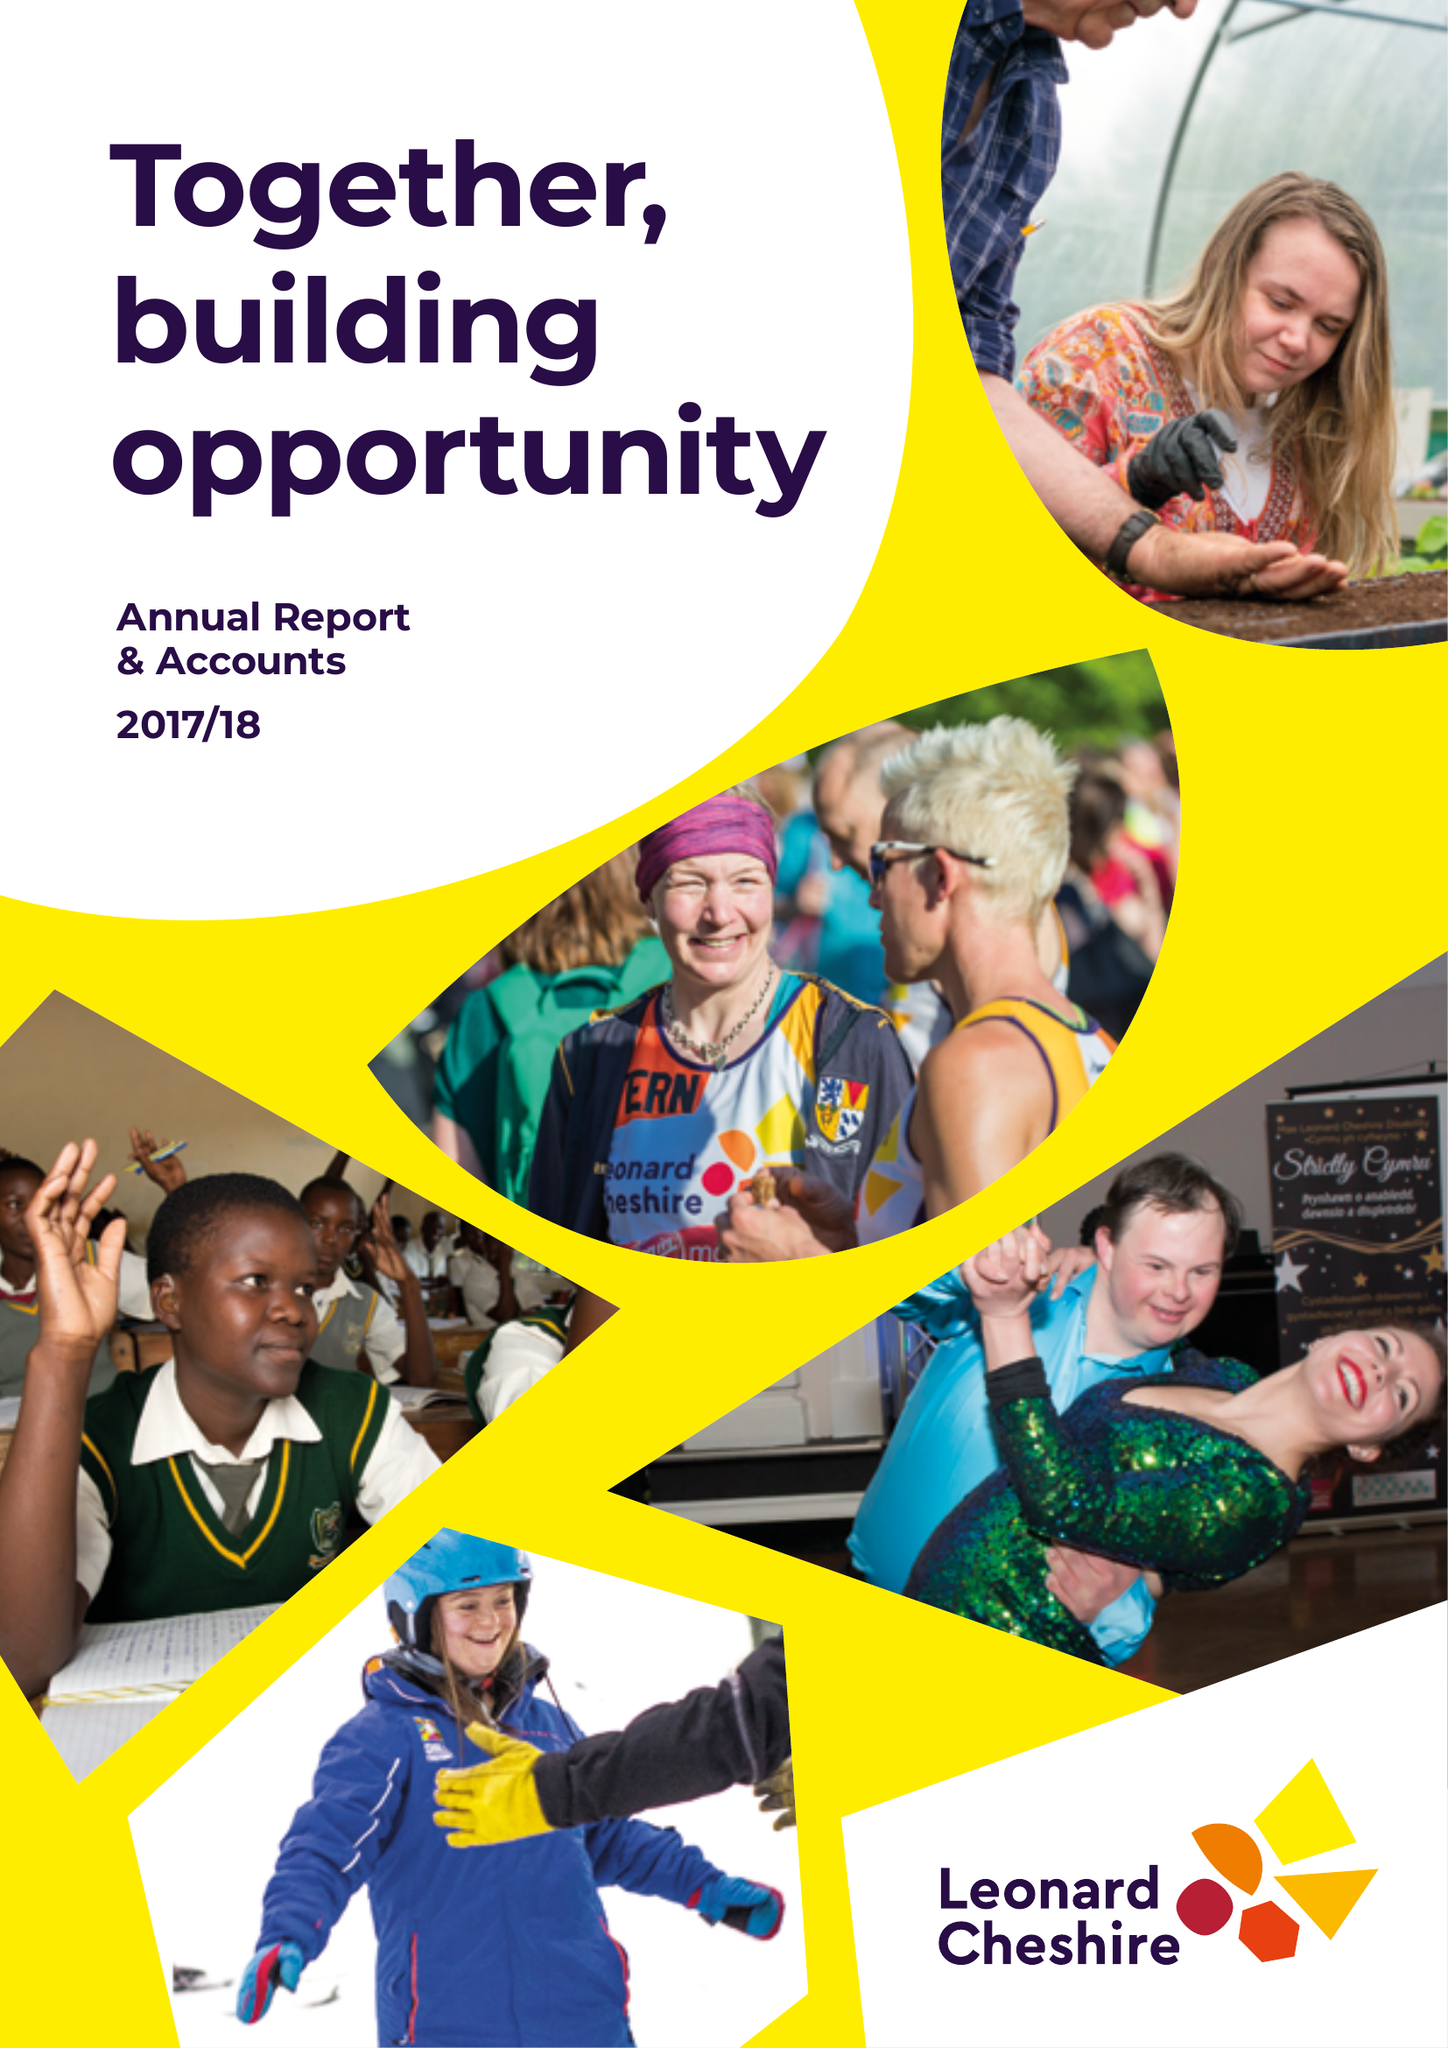What is the value for the address__postcode?
Answer the question using a single word or phrase. SW8 1RL 